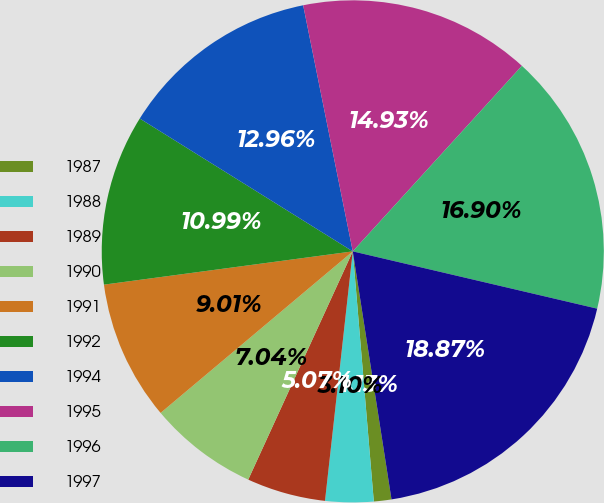Convert chart to OTSL. <chart><loc_0><loc_0><loc_500><loc_500><pie_chart><fcel>1987<fcel>1988<fcel>1989<fcel>1990<fcel>1991<fcel>1992<fcel>1994<fcel>1995<fcel>1996<fcel>1997<nl><fcel>1.13%<fcel>3.1%<fcel>5.07%<fcel>7.04%<fcel>9.01%<fcel>10.99%<fcel>12.96%<fcel>14.93%<fcel>16.9%<fcel>18.87%<nl></chart> 